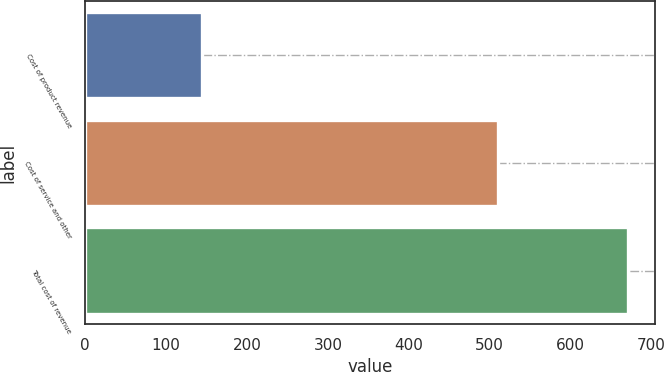Convert chart to OTSL. <chart><loc_0><loc_0><loc_500><loc_500><bar_chart><fcel>Cost of product revenue<fcel>Cost of service and other<fcel>Total cost of revenue<nl><fcel>144<fcel>510<fcel>671<nl></chart> 